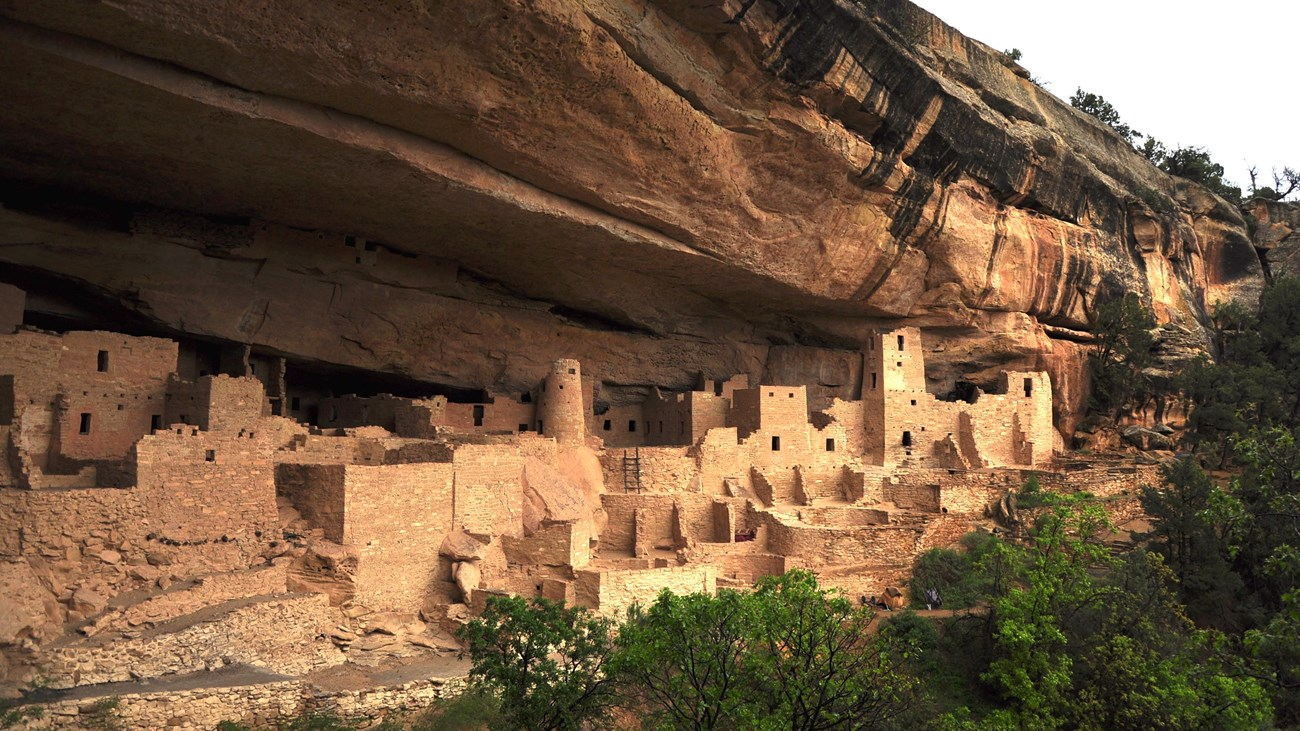If you could go back in time and experience one day in the lives of the ancient Puebloans living here, what would be the most remarkable moment? Going back in time to experience one day in the lives of the ancient Puebloans living in these cliff dwellings, the most remarkable moment would likely be witnessing a communal ceremony or ritual. These events were pivotal in their culture, often involving intricate dances, music, and storytelling that conveyed their spiritual beliefs and strengthened community bonds. Observing such a ceremony would provide deep insight into their values, social structure, and the communal harmony that enabled them to thrive in such challenging conditions. The connection to their heritage and the unity of their society would be profoundly moving and enlightening. 